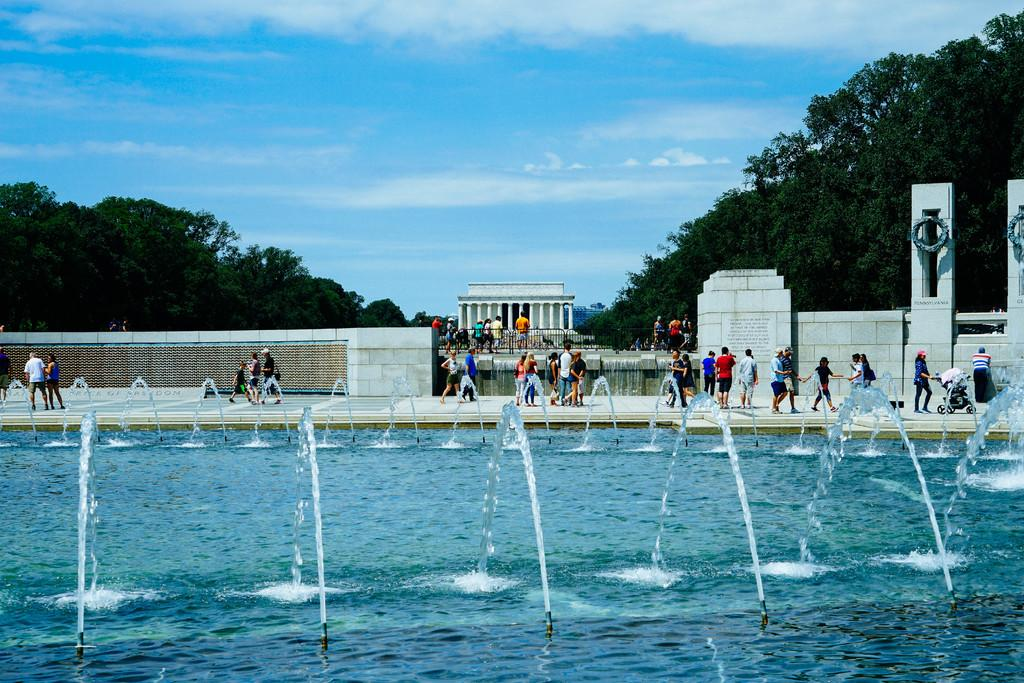What is the primary element visible in the image? There is water in the image. Can you describe the people in the image? There are persons in the image. What architectural features can be seen in the background? There is a wall and pillars in the background of the image. What type of vegetation is visible in the background? There are trees in the background of the image. What is visible in the sky in the image? The sky is visible in the background of the image, and clouds are present. What type of brass instrument is being played by the horses in the image? There are no horses or brass instruments present in the image. 